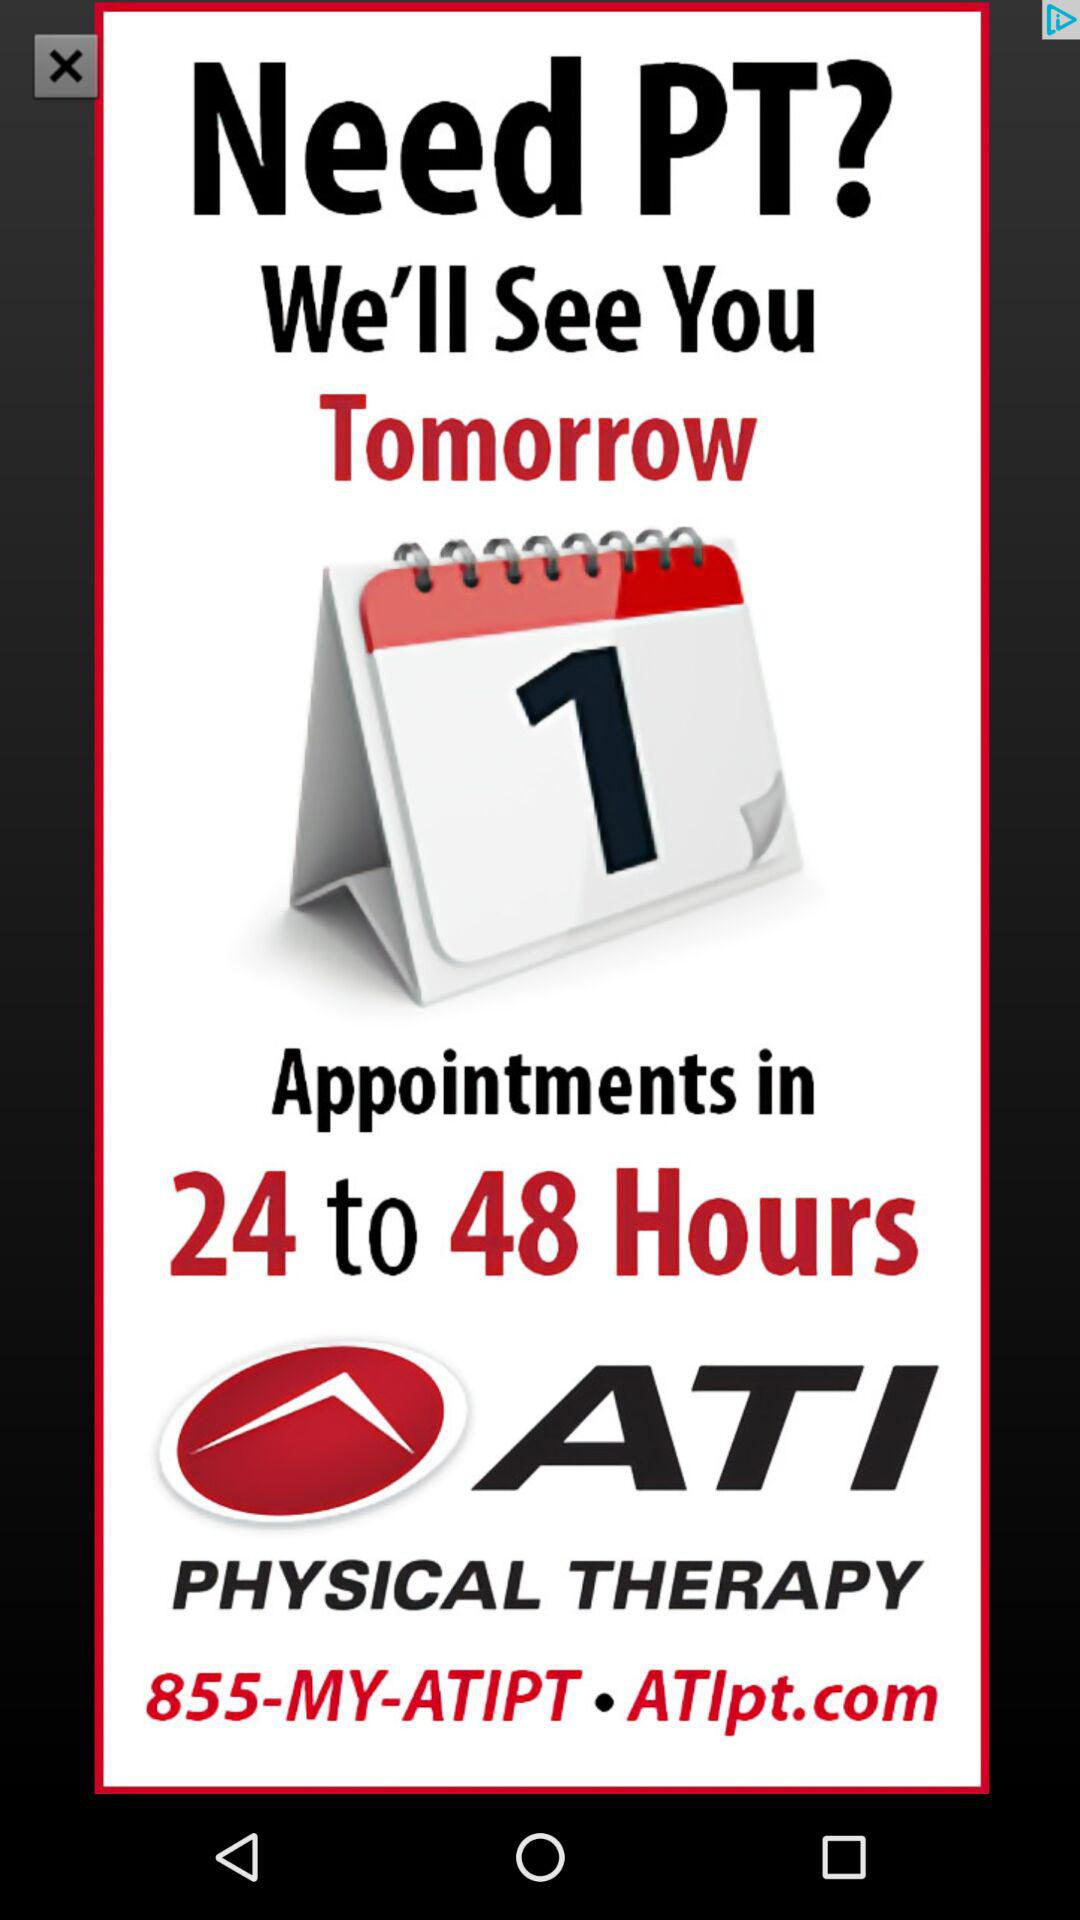How many more hours are available for appointments than days?
Answer the question using a single word or phrase. 24 